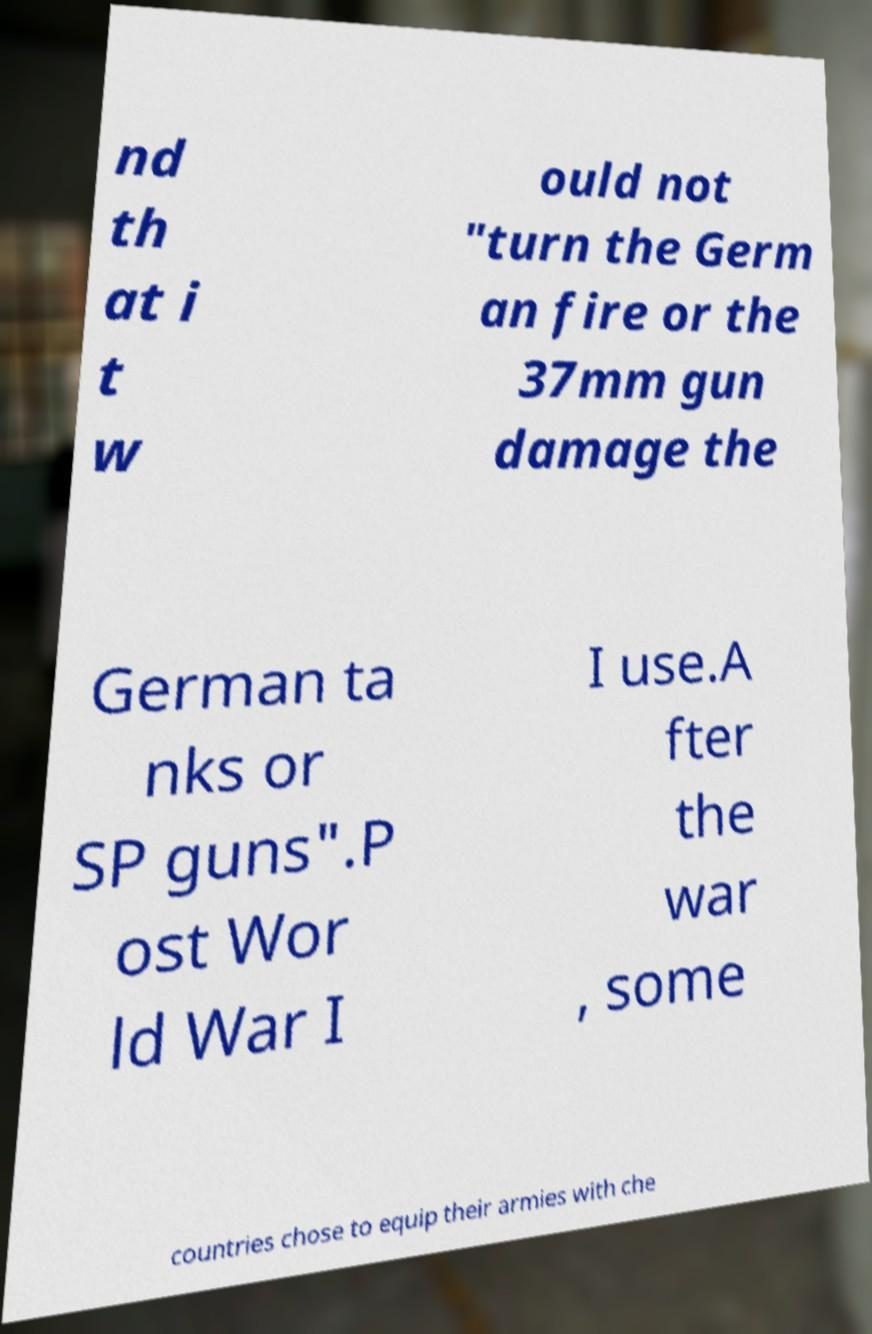Could you assist in decoding the text presented in this image and type it out clearly? nd th at i t w ould not "turn the Germ an fire or the 37mm gun damage the German ta nks or SP guns".P ost Wor ld War I I use.A fter the war , some countries chose to equip their armies with che 